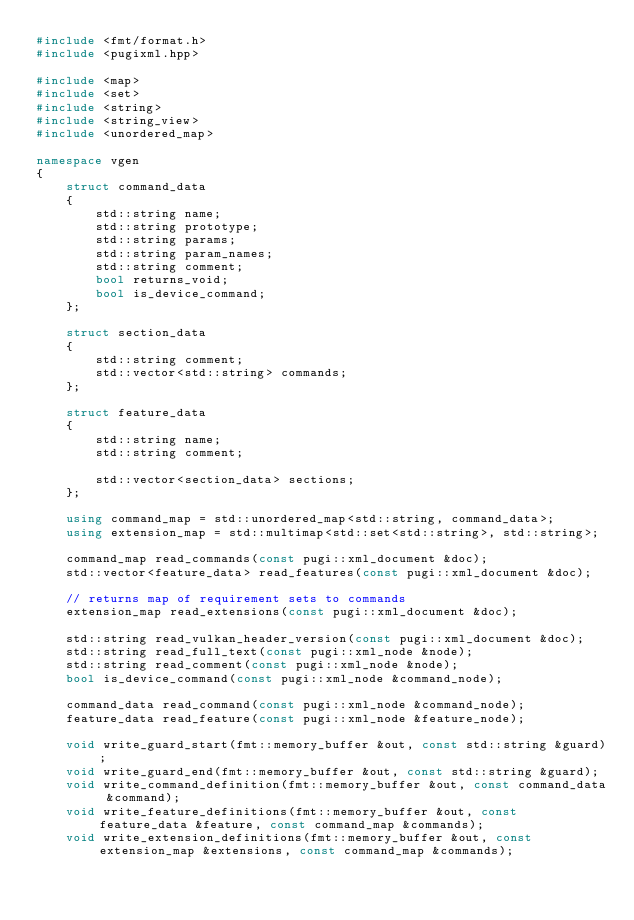<code> <loc_0><loc_0><loc_500><loc_500><_C++_>#include <fmt/format.h>
#include <pugixml.hpp>

#include <map>
#include <set>
#include <string>
#include <string_view>
#include <unordered_map>

namespace vgen
{
	struct command_data
	{
		std::string name;
		std::string prototype;
		std::string params;
		std::string param_names;
		std::string comment;
		bool returns_void;
		bool is_device_command;
	};

	struct section_data
	{
		std::string comment;
		std::vector<std::string> commands;
	};

	struct feature_data
	{
		std::string name;
		std::string comment;

		std::vector<section_data> sections;
	};

	using command_map = std::unordered_map<std::string, command_data>;
	using extension_map = std::multimap<std::set<std::string>, std::string>;

	command_map read_commands(const pugi::xml_document &doc);
	std::vector<feature_data> read_features(const pugi::xml_document &doc);

	// returns map of requirement sets to commands
	extension_map read_extensions(const pugi::xml_document &doc);

	std::string read_vulkan_header_version(const pugi::xml_document &doc);
	std::string read_full_text(const pugi::xml_node &node);
	std::string read_comment(const pugi::xml_node &node);
	bool is_device_command(const pugi::xml_node &command_node);

	command_data read_command(const pugi::xml_node &command_node);
	feature_data read_feature(const pugi::xml_node &feature_node);

	void write_guard_start(fmt::memory_buffer &out, const std::string &guard);
	void write_guard_end(fmt::memory_buffer &out, const std::string &guard);
	void write_command_definition(fmt::memory_buffer &out, const command_data &command);
	void write_feature_definitions(fmt::memory_buffer &out, const feature_data &feature, const command_map &commands);
	void write_extension_definitions(fmt::memory_buffer &out, const extension_map &extensions, const command_map &commands);
</code> 